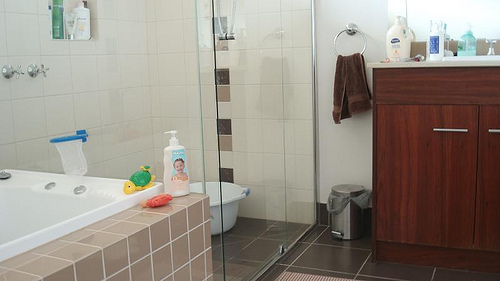Please provide a short description for this region: [0.74, 0.24, 0.99, 0.35]. Various toiletry bottles and containers neatly arranged across the top of a bathroom counter. 